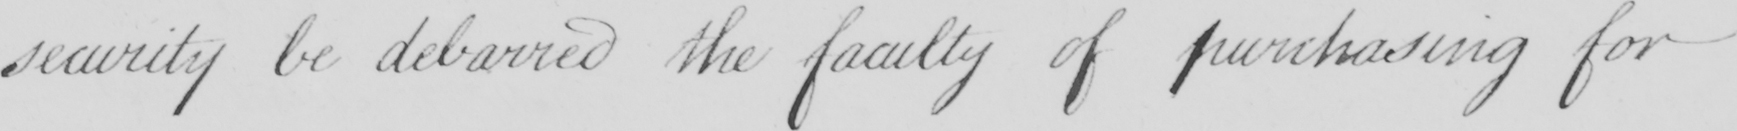What text is written in this handwritten line? security be debarred the faculty of purchasing for 